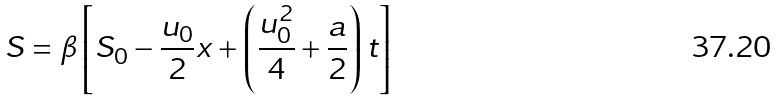Convert formula to latex. <formula><loc_0><loc_0><loc_500><loc_500>S = \beta \left [ S _ { 0 } - \frac { u _ { 0 } } { 2 } x + \left ( \frac { u _ { 0 } ^ { 2 } } { 4 } + \frac { a } { 2 } \right ) t \right ]</formula> 